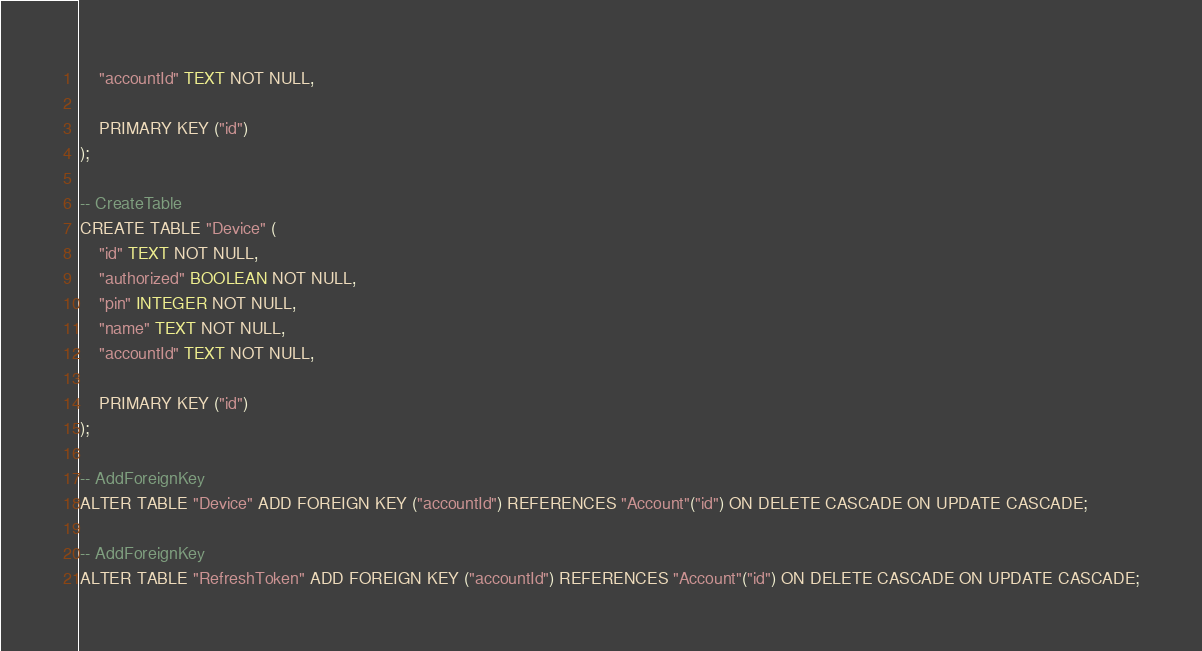<code> <loc_0><loc_0><loc_500><loc_500><_SQL_>    "accountId" TEXT NOT NULL,

    PRIMARY KEY ("id")
);

-- CreateTable
CREATE TABLE "Device" (
    "id" TEXT NOT NULL,
    "authorized" BOOLEAN NOT NULL,
    "pin" INTEGER NOT NULL,
    "name" TEXT NOT NULL,
    "accountId" TEXT NOT NULL,

    PRIMARY KEY ("id")
);

-- AddForeignKey
ALTER TABLE "Device" ADD FOREIGN KEY ("accountId") REFERENCES "Account"("id") ON DELETE CASCADE ON UPDATE CASCADE;

-- AddForeignKey
ALTER TABLE "RefreshToken" ADD FOREIGN KEY ("accountId") REFERENCES "Account"("id") ON DELETE CASCADE ON UPDATE CASCADE;
</code> 